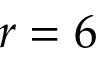Convert formula to latex. <formula><loc_0><loc_0><loc_500><loc_500>r = 6</formula> 